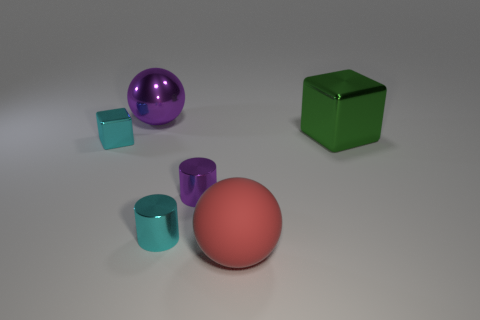Subtract all yellow balls. Subtract all blue cylinders. How many balls are left? 2 Add 3 big yellow rubber balls. How many objects exist? 9 Subtract all balls. How many objects are left? 4 Subtract all tiny purple metallic cubes. Subtract all tiny metal cylinders. How many objects are left? 4 Add 4 cyan things. How many cyan things are left? 6 Add 5 metal objects. How many metal objects exist? 10 Subtract 0 blue balls. How many objects are left? 6 